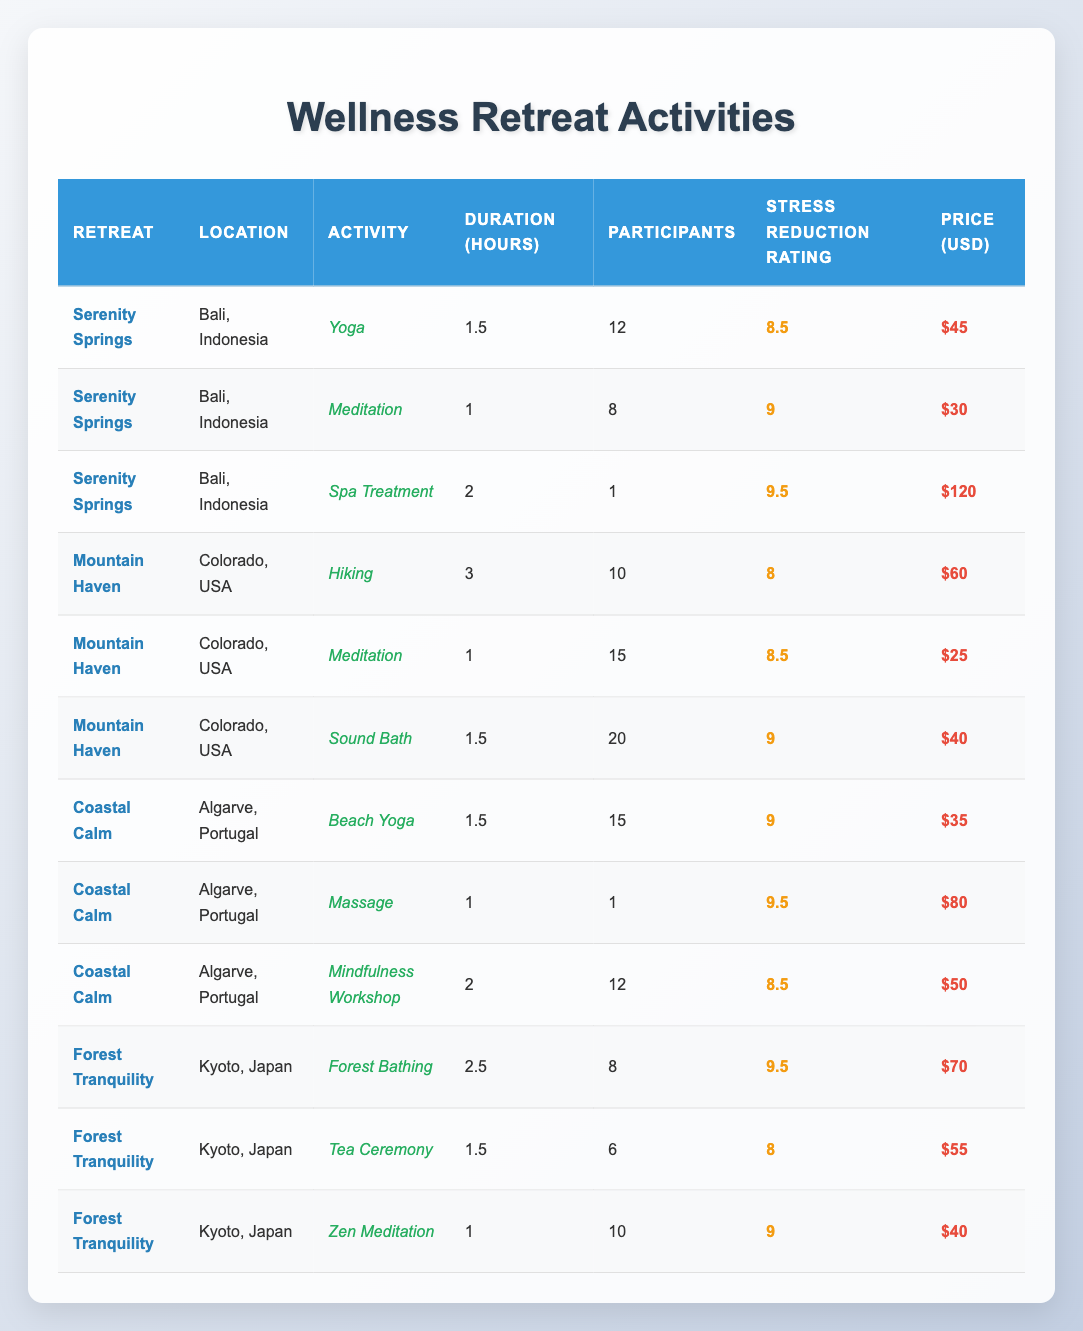What is the highest Stress Reduction Rating among all activities? The highest Stress Reduction Rating is listed in the table. Scanning through the ratings: 9, 9.5, and 8 are present. The maximum value is 9.5, which appears for both the Spa Treatment at Serenity Springs and the Massage at Coastal Calm.
Answer: 9.5 Which activity at Forest Tranquility has the most participants? In the Forest Tranquility section, we have Forest Bathing (8 participants), Tea Ceremony (6 participants), and Zen Meditation (10 participants). The Zen Meditation has the most at 10 participants.
Answer: Zen Meditation What is the average duration of activities offered at Coastal Calm? The activities at Coastal Calm are Beach Yoga (1.5 hours), Massage (1 hour), and Mindfulness Workshop (2 hours). Summing the durations gives 1.5 + 1 + 2 = 4.5 hours. Dividing by the number of activities (3) gives 4.5/3 = 1.5 hours.
Answer: 1.5 hours Does any activity in Mountain Haven have a Stress Reduction Rating higher than 9? Checking the Stress Reduction Ratings for Mountain Haven: Hiking has 8, Meditation has 8.5, and Sound Bath has 9. None exceed 9, so the answer is no.
Answer: No Which retreat has the most expensive activity, and what is the price? Among all activities, the Spa Treatment at Serenity Springs is priced at 120 USD. The next highest price is 80 USD from the Massage at Coastal Calm. Thus, the most expensive activity is the Spa Treatment at 120 USD.
Answer: Serenity Springs, 120 USD What is the total number of participants across all activities at Serenity Springs? For Serenity Springs, the number of participants are: Yoga (12), Meditation (8), Spa Treatment (1). Adding these gives 12 + 8 + 1 = 21 participants.
Answer: 21 participants What is the Stress Reduction Rating for the Beach Yoga activity? The Beach Yoga activity under Coastal Calm has a Stress Reduction Rating of 9.
Answer: 9 Which location offers the longest single activity, and what is the duration? By reviewing the durations, the longest activity is Hiking at Mountain Haven with 3 hours. Other activities have shorter durations. So, Mountain Haven offers the longest activity duration.
Answer: Mountain Haven, 3 hours What percentage of participants in the Coastal Calm activities rated Stress Reduction above 9? In Coastal Calm, Beach Yoga has 15 participants with a rating of 9, Massage has 1 participant with a rating of 9.5. Thus, 1 out of 16 participants (1/16 = 0.0625) rated above 9, which converts to approximately 6.25%.
Answer: 6.25% 